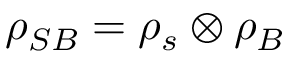Convert formula to latex. <formula><loc_0><loc_0><loc_500><loc_500>\rho _ { S B } = \rho _ { s } \otimes \rho _ { B }</formula> 